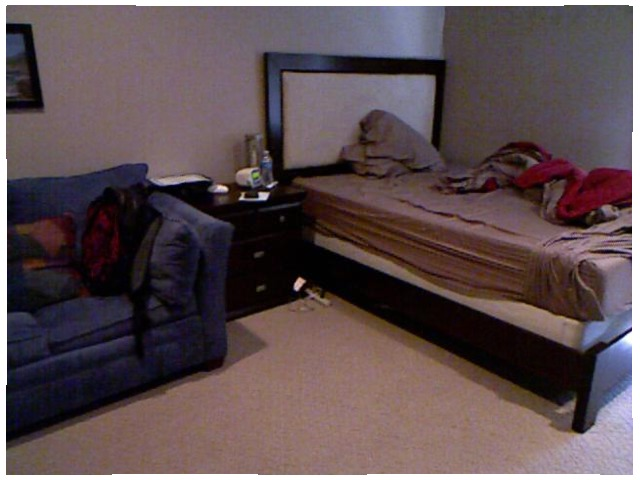<image>
Can you confirm if the dresser is on the couch? No. The dresser is not positioned on the couch. They may be near each other, but the dresser is not supported by or resting on top of the couch. Is the bed behind the table? No. The bed is not behind the table. From this viewpoint, the bed appears to be positioned elsewhere in the scene. Where is the sofa in relation to the bed? Is it to the right of the bed? No. The sofa is not to the right of the bed. The horizontal positioning shows a different relationship. 